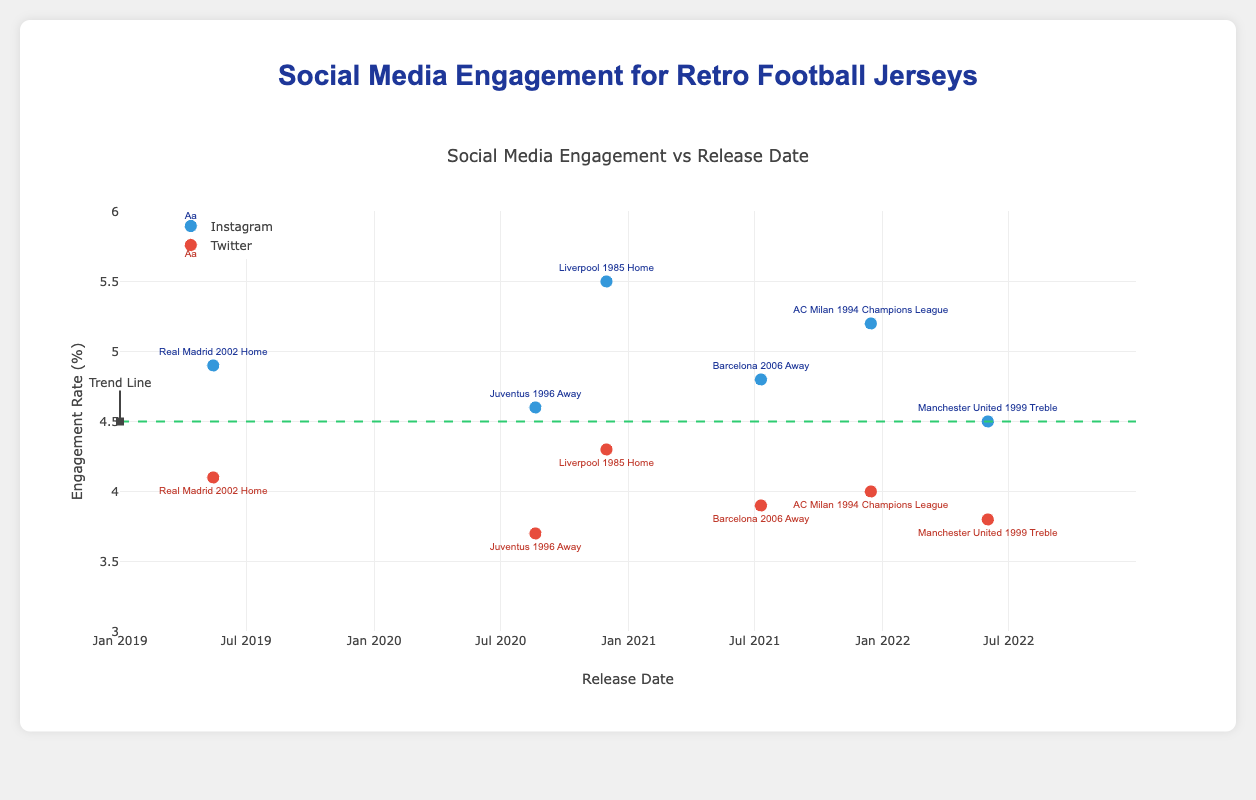How many social media platforms are represented in the figure? The figure includes data points related to engagement rates on both Instagram and Twitter.
Answer: 2 What's the average engagement rate for Instagram posts? To find the average engagement rate for Instagram, sum the engagement rates (4.5 + 5.2 + 4.8 + 5.5 + 4.6 + 4.9) and divide by the number of data points (6). So, the average is (4.5 + 5.2 + 4.8 + 5.5 + 4.6 + 4.9) / 6 = 4.92.
Answer: 4.92 Which jersey had the highest engagement rate on Instagram, and what was the rate? By observing the Instagram engagement rates, the "Liverpool 1985 Home" jersey had the highest engagement rate of 5.5.
Answer: Liverpool 1985 Home, 5.5 What is the trend line indicating in terms of engagement rates over the years? The trend line is horizontal at an engagement rate of 4.5, indicating no increase or decrease in the average engagement rates over the years.
Answer: No change How does the engagement rate for "Manchester United 1999 Treble" on Twitter compare with its engagement rate on Instagram? The engagement rate for "Manchester United 1999 Treble" on Twitter is 3.8, while on Instagram, it is 4.5. Therefore, the Twitter engagement rate is lower.
Answer: Lower What is the difference in engagement rates between Instagram and Twitter for the "Barcelona 2006 Away" jersey? On Instagram, the engagement rate for the "Barcelona 2006 Away" jersey is 4.8, while on Twitter, it is 3.9. The difference is 4.8 - 3.9 = 0.9.
Answer: 0.9 Which platform shows more variation in engagement rates, Instagram or Twitter? By comparing the range of engagement rates on both platforms, Instagram varies from 4.5 to 5.5 (range = 1), while Twitter ranges from 3.7 to 4.3 (range = 0.6). Therefore, Instagram shows more variation.
Answer: Instagram What is the engagement rate trend for jerseys released closer to 2022 compared to those released in earlier years? Jerseys released closer to 2022 generally have high engagement rates similar to the ones released in earlier years, as indicated by consistently high engagement figures around the 4.5 trend line and above for both newer and older releases.
Answer: Consistent and high How many data points are plotted for Instagram and Twitter separately? There are 6 data points plotted for Instagram and 6 for Twitter, as each jersey's engagement rate is presented on both platforms.
Answer: 6 for each Which jersey has the lowest engagement rate on Twitter? By observing the plotted engagement rates on Twitter, the "Juventus 1996 Away" jersey has the lowest engagement rate of 3.7.
Answer: Juventus 1996 Away, 3.7 